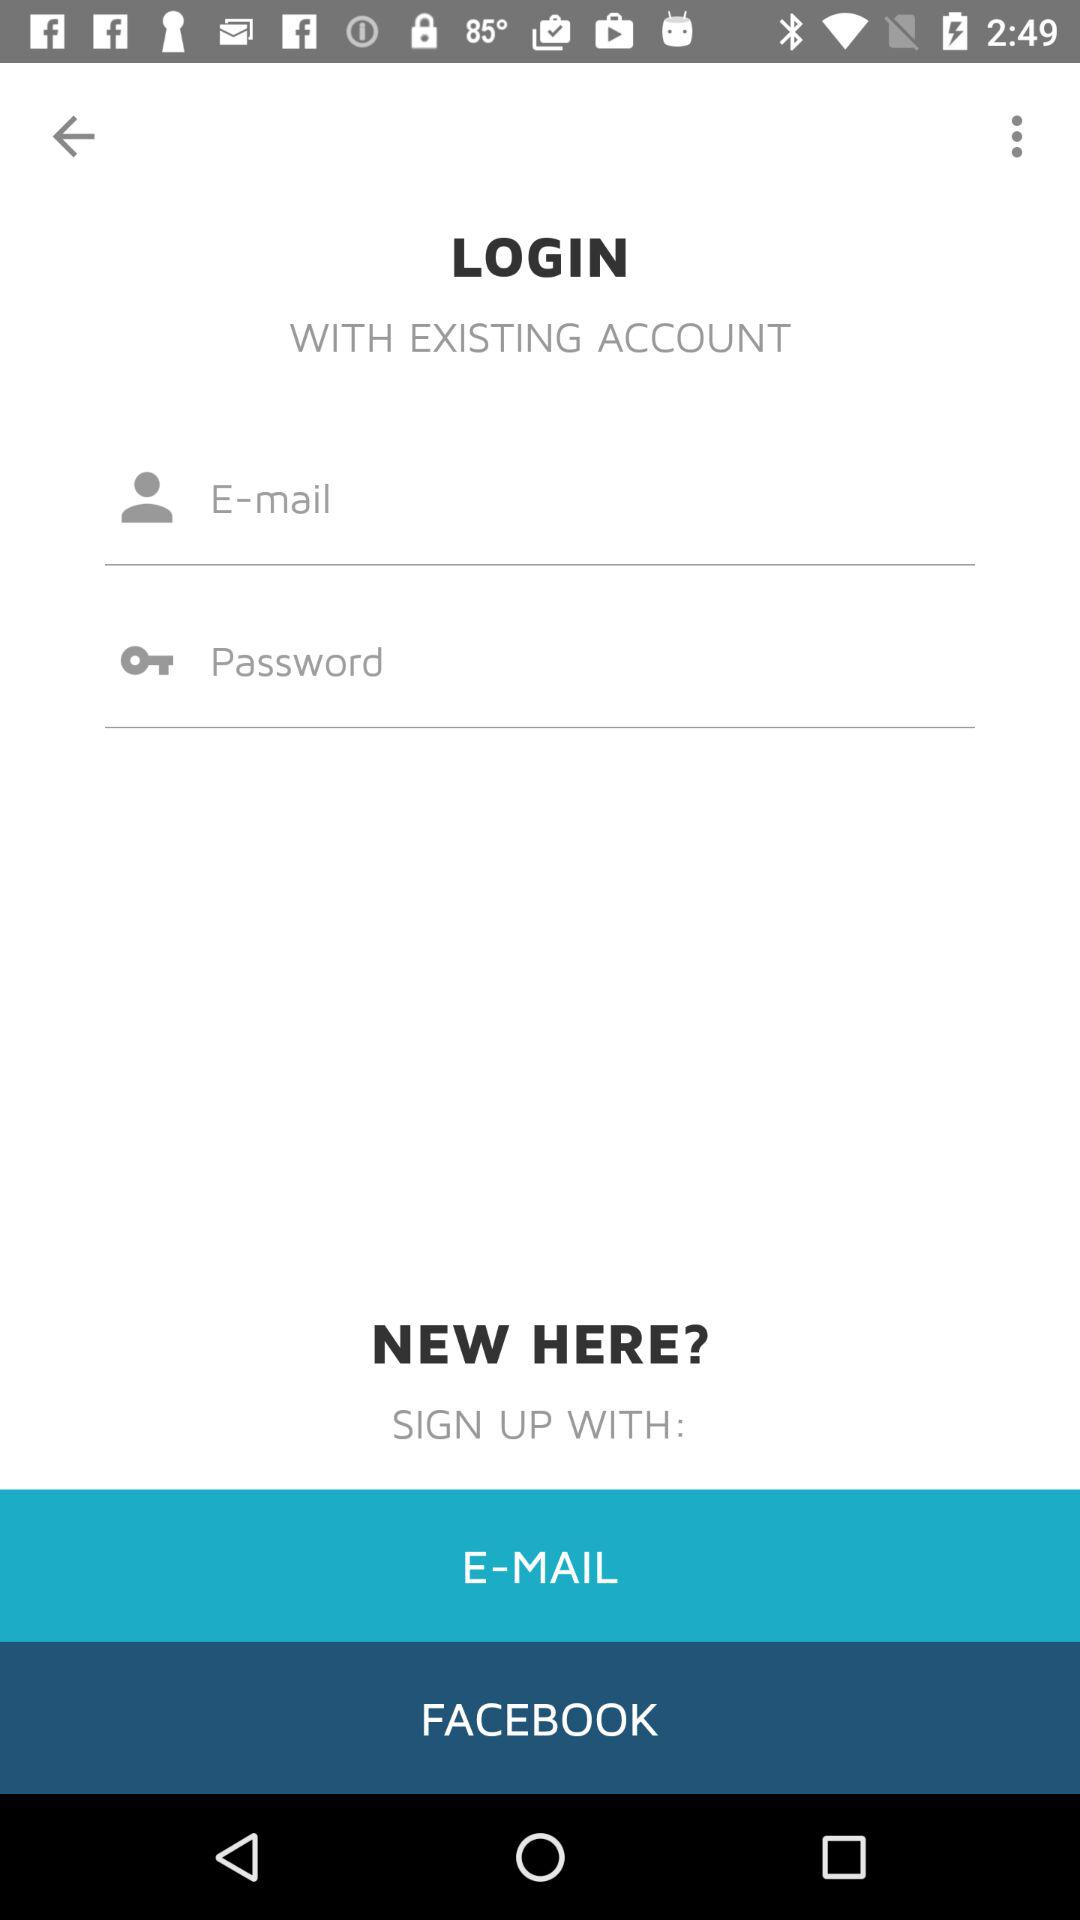What accounts can I use to sign up? The accounts that can be used to sign up are: "E-MAIL" and "FACEBOOK". 